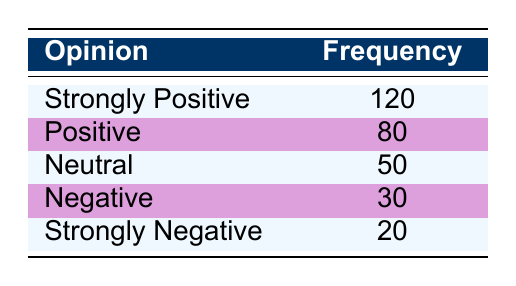What is the frequency of the "Positive" opinion? The table lists the frequency associated with the opinion "Positive," which is directly stated as 80 in the corresponding row.
Answer: 80 What is the highest opinion category and its frequency? By examining the frequency column, the highest frequency is found next to "Strongly Positive," which has a frequency of 120.
Answer: Strongly Positive, 120 What is the total frequency of all opinions combined? To find the total frequency, we sum up all the provided frequencies: 120 + 80 + 50 + 30 + 20 = 300.
Answer: 300 What percentage of respondents view floor-crossing negatively or strongly negatively? The frequencies for "Negative" and "Strongly Negative" are 30 and 20 respectively. Adding these gives 30 + 20 = 50. To find the percentage of the total (300), we calculate (50 / 300) * 100 = 16.67%.
Answer: 16.67% Is the frequency of "Neutral" opinions higher than that of "Negative" opinions? The frequency for "Neutral" is 50, while "Negative" is 30. Since 50 is greater than 30, it is true that the frequency of "Neutral" opinions is higher.
Answer: Yes Which opinion has the lowest frequency, and what is that frequency? Looking through the frequency column, the opinion "Strongly Negative" has the lowest frequency listed at 20.
Answer: Strongly Negative, 20 If we combine the frequencies of "Strongly Positive" and "Positive," what is the total? The frequencies for "Strongly Positive" (120) and "Positive" (80) are added together: 120 + 80 = 200.
Answer: 200 How many more people had a "Strongly Positive" opinion compared to a "Strongly Negative" opinion? The difference in frequency is calculated by subtracting the frequency of "Strongly Negative" (20) from "Strongly Positive" (120): 120 - 20 = 100.
Answer: 100 What is the median opinion based on the frequency distribution provided? To find the median, we need to arrange the opinions in order of frequency: [20 (Strongly Negative), 30 (Negative), 50 (Neutral), 80 (Positive), 120 (Strongly Positive)]. The middle value for 5 data points is the third one: Neutral, which has a frequency of 50.
Answer: 50 